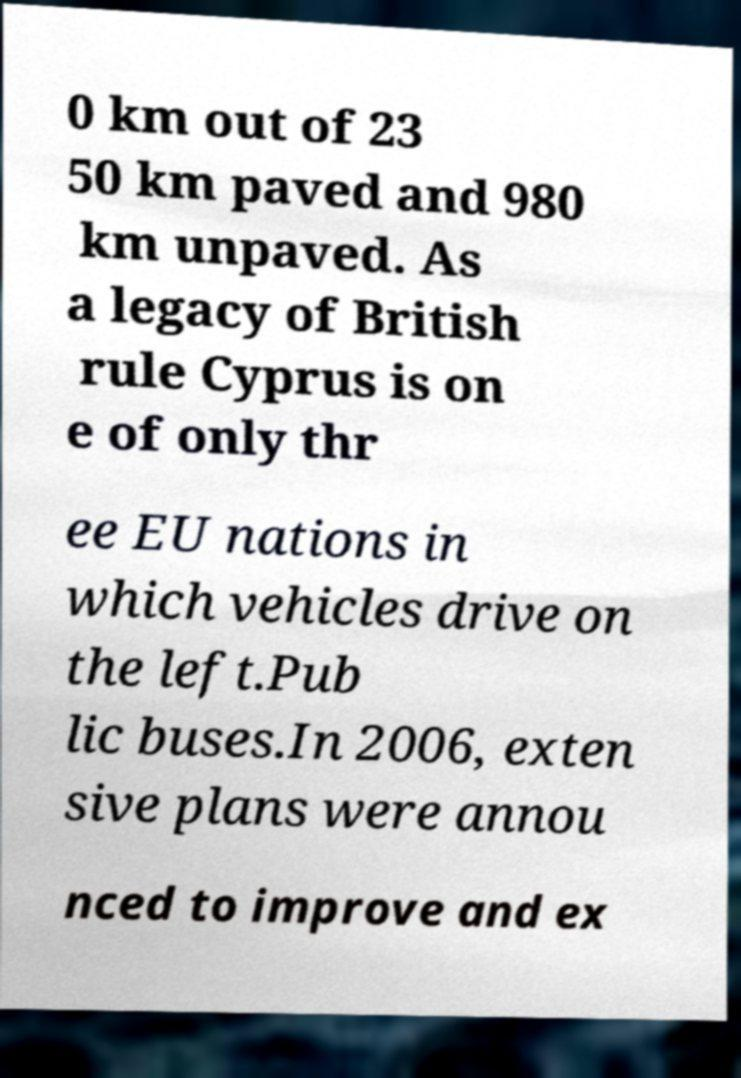What messages or text are displayed in this image? I need them in a readable, typed format. 0 km out of 23 50 km paved and 980 km unpaved. As a legacy of British rule Cyprus is on e of only thr ee EU nations in which vehicles drive on the left.Pub lic buses.In 2006, exten sive plans were annou nced to improve and ex 